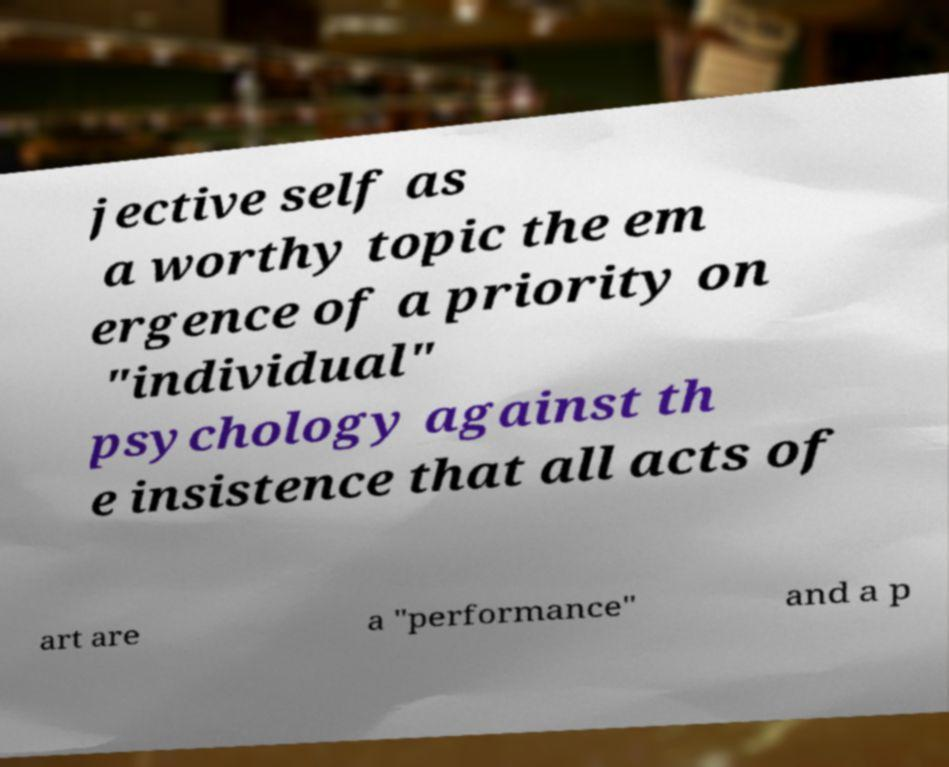Please read and relay the text visible in this image. What does it say? jective self as a worthy topic the em ergence of a priority on "individual" psychology against th e insistence that all acts of art are a "performance" and a p 